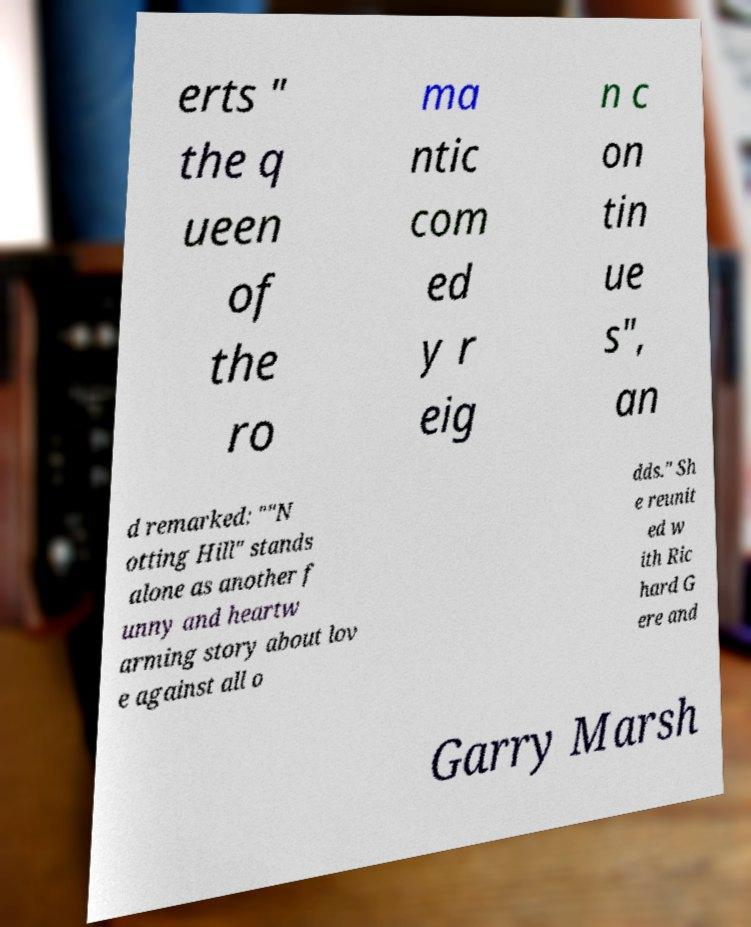There's text embedded in this image that I need extracted. Can you transcribe it verbatim? erts " the q ueen of the ro ma ntic com ed y r eig n c on tin ue s", an d remarked: ""N otting Hill" stands alone as another f unny and heartw arming story about lov e against all o dds." Sh e reunit ed w ith Ric hard G ere and Garry Marsh 